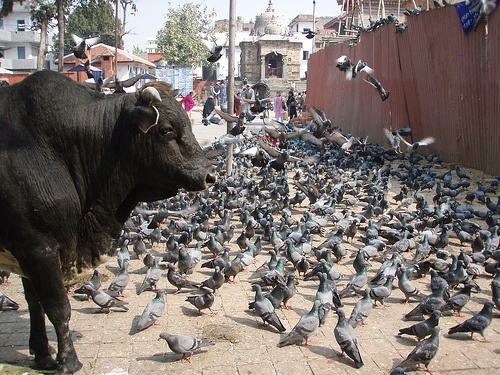Describe the objects in this image and their specific colors. I can see bird in lightblue, gray, black, darkgray, and lightgray tones, cow in lightblue, black, and gray tones, bird in lightblue, darkgray, gray, lightgray, and tan tones, bird in lightblue, darkgray, lightgray, and gray tones, and bird in lightblue, gray, darkgray, lightgray, and black tones in this image. 